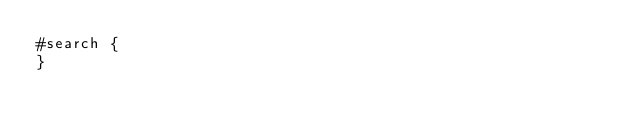<code> <loc_0><loc_0><loc_500><loc_500><_CSS_>#search {
}
</code> 